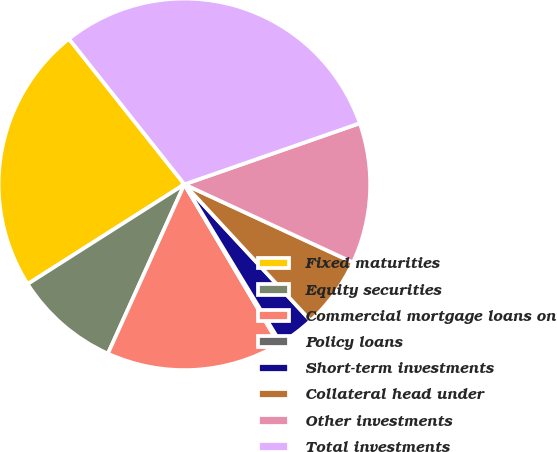<chart> <loc_0><loc_0><loc_500><loc_500><pie_chart><fcel>Fixed maturities<fcel>Equity securities<fcel>Commercial mortgage loans on<fcel>Policy loans<fcel>Short-term investments<fcel>Collateral head under<fcel>Other investments<fcel>Total investments<nl><fcel>23.34%<fcel>9.23%<fcel>15.26%<fcel>0.18%<fcel>3.2%<fcel>6.21%<fcel>12.24%<fcel>30.34%<nl></chart> 